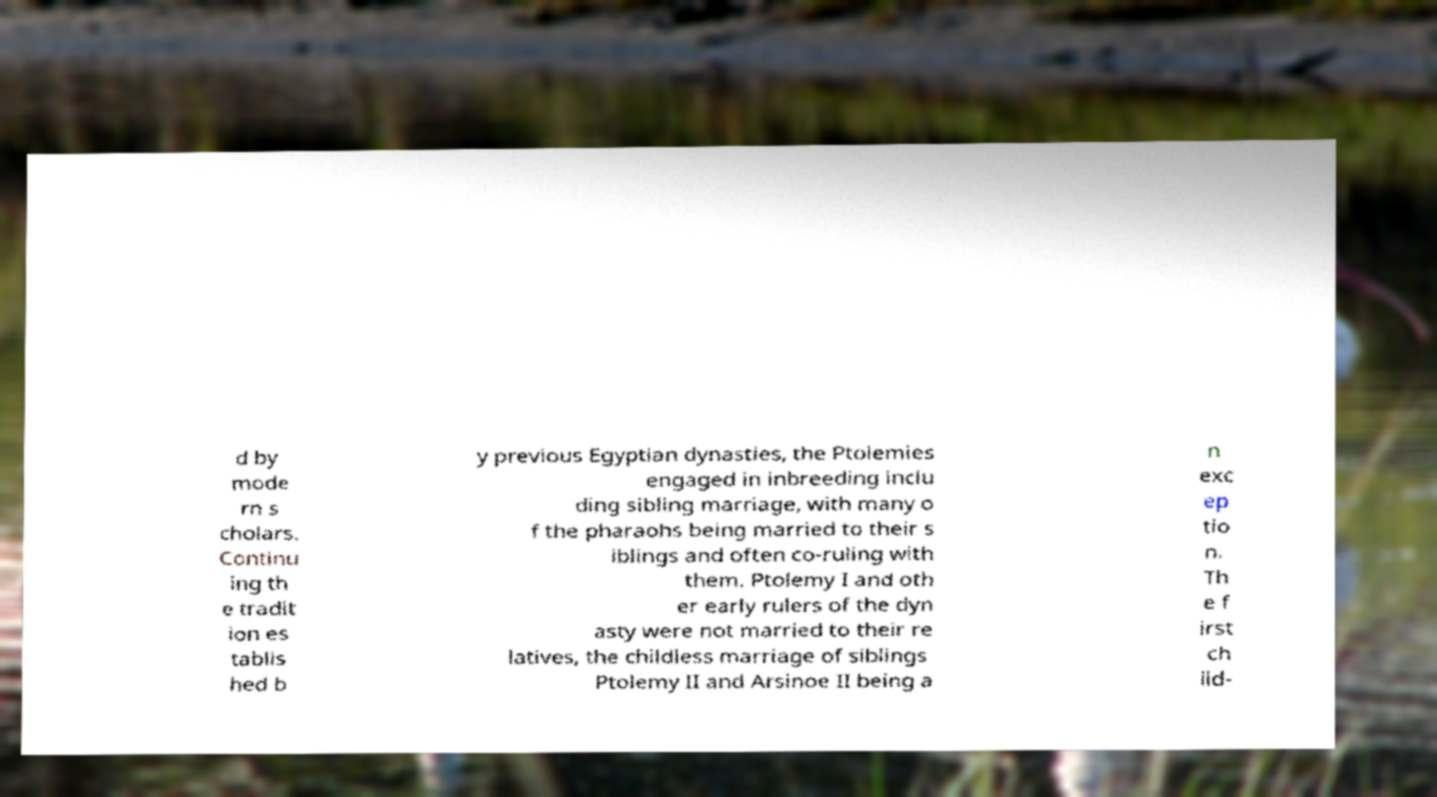Please identify and transcribe the text found in this image. d by mode rn s cholars. Continu ing th e tradit ion es tablis hed b y previous Egyptian dynasties, the Ptolemies engaged in inbreeding inclu ding sibling marriage, with many o f the pharaohs being married to their s iblings and often co-ruling with them. Ptolemy I and oth er early rulers of the dyn asty were not married to their re latives, the childless marriage of siblings Ptolemy II and Arsinoe II being a n exc ep tio n. Th e f irst ch ild- 